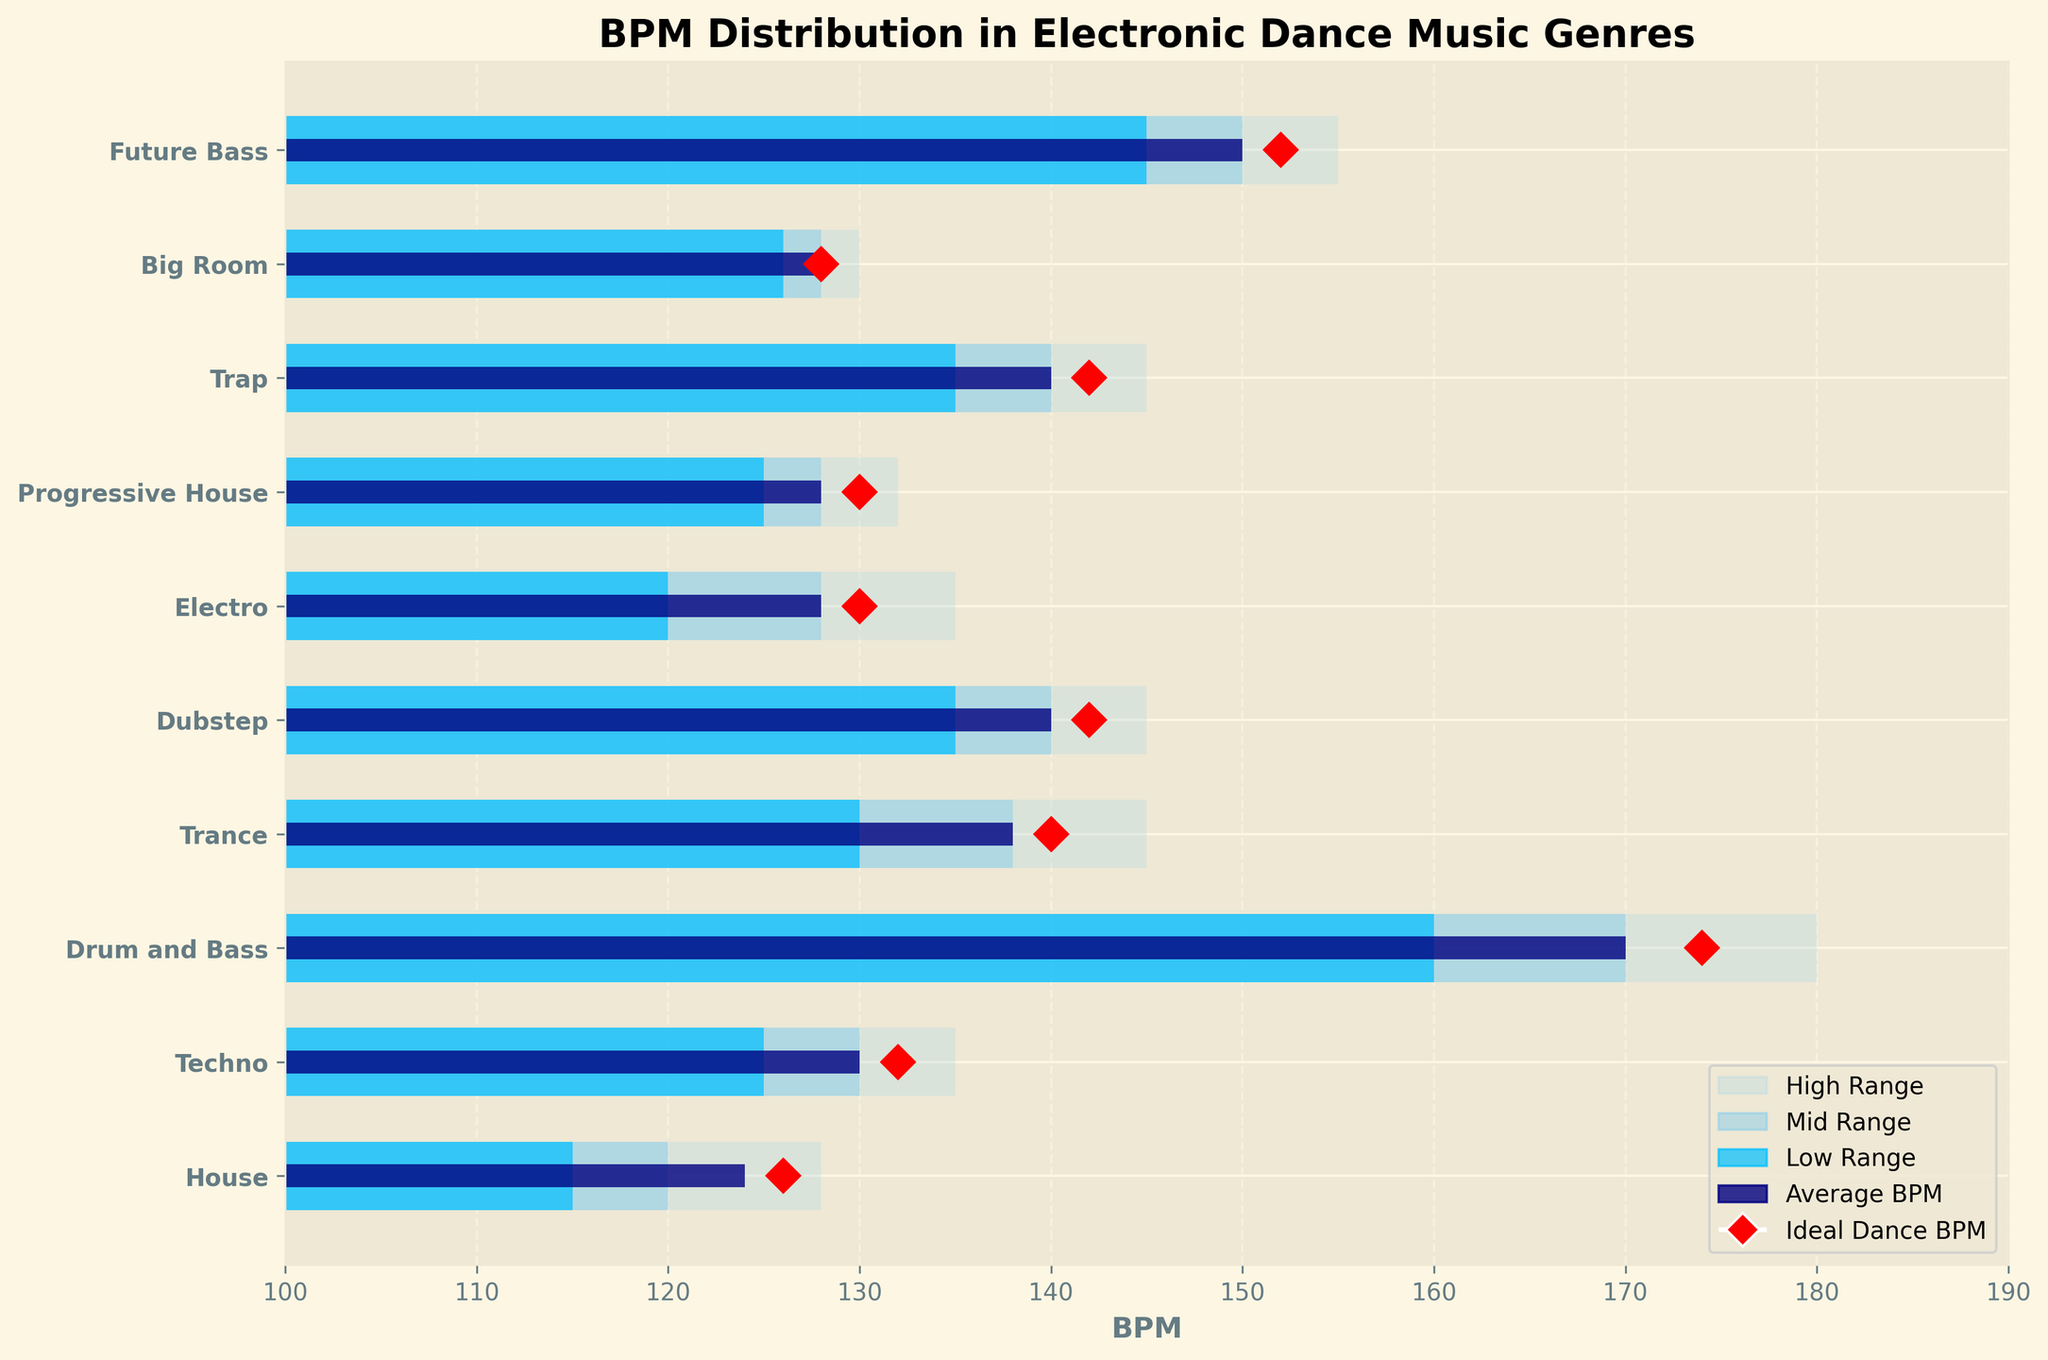Which genre has the highest average BPM? The genre with the highest average BPM is Drum and Bass. From the chart, Drum and Bass shows an average BPM of 170, which is higher than any other genre displayed.
Answer: Drum and Bass What is the BPM range for Trance? Trance has three distinct BPM ranges highlighted in the chart. The low range starts at 130 BPM, the mid range starts at 138 BPM, and the high range starts at 145 BPM. From this, we can conclude the BPM range for Trance is from 130 to 145 BPM.
Answer: 130 to 145 BPM What's the ideal dance BPM for House music, and how does it compare to the ideal dance BPM for Electro? The ideal dance BPM for House music is marked as 126 BPM, and for Electro, it is marked as 130 BPM. Comparing these values, House's ideal BPM is 4 BPM lower than Electro's.
Answer: House: 126 BPM, Electro: 130 BPM; House is 4 BPM lower In which genres does the average BPM fall within the mid-range? By examining the chart, we see that the average BPM falls within the mid-range for Techno, Drum and Bass, Trance, Dubstep, Progressive House, Trap, and Future Bass. This is identified by the average BPM bars aligning within the boundaries of the mid-range highlighted regions.
Answer: Techno, Drum and Bass, Trance, Dubstep, Progressive House, Trap, Future Bass Which genre has the narrowest total BPM range and what is that range? The genre with the narrowest total BPM range is Big Room. The low range starts at 126 BPM and the high range ends at 130 BPM, so the total range is from 126 to 130 BPM, making it a 4 BPM range.
Answer: Big Room, 4 BPM (126 to 130 BPM) Which genre's ideal BPM marker is closest to its average BPM? By observing the position of the ideal BPM markers relative to the average BPM bars, it is clear that Big Room's ideal BPM marker at 128 is very close to its average BPM of 128. Hence, they are essentially equal.
Answer: Big Room What's the difference between the ideal dance BPM for Drum and Bass and Future Bass? The ideal BPM for Drum and Bass is 174 BPM, and for Future Bass, it is 152 BPM. The difference between these two values is 174 - 152 = 22 BPM.
Answer: 22 BPM Is there any genre in which the low range BPM is higher than the average BPM of any other genre? The low range BPM of Drum and Bass starts at 160 BPM, which is higher than the average BPM of any other genre except for Drum and Bass itself.
Answer: Yes, Drum and Bass Which genres have a high range BPM that exceeds 150 BPM? Reviewing the high range values on the chart, Drum and Bass, Trap, and Future Bass have high range BPMs that exceed 150 BPM (180, 145, and 155 respectively).
Answer: Drum and Bass, Trap, Future Bass What is the overlapping BPM range of Dubstep and Trap? Examining the BPM ranges for both Dubstep and Trap, both genres have mid-range BPM starting at 140 and high-range topping at 145 BPM. Thus, the overlapping BPM range is 140 to 145 BPM.
Answer: 140 to 145 BPM 